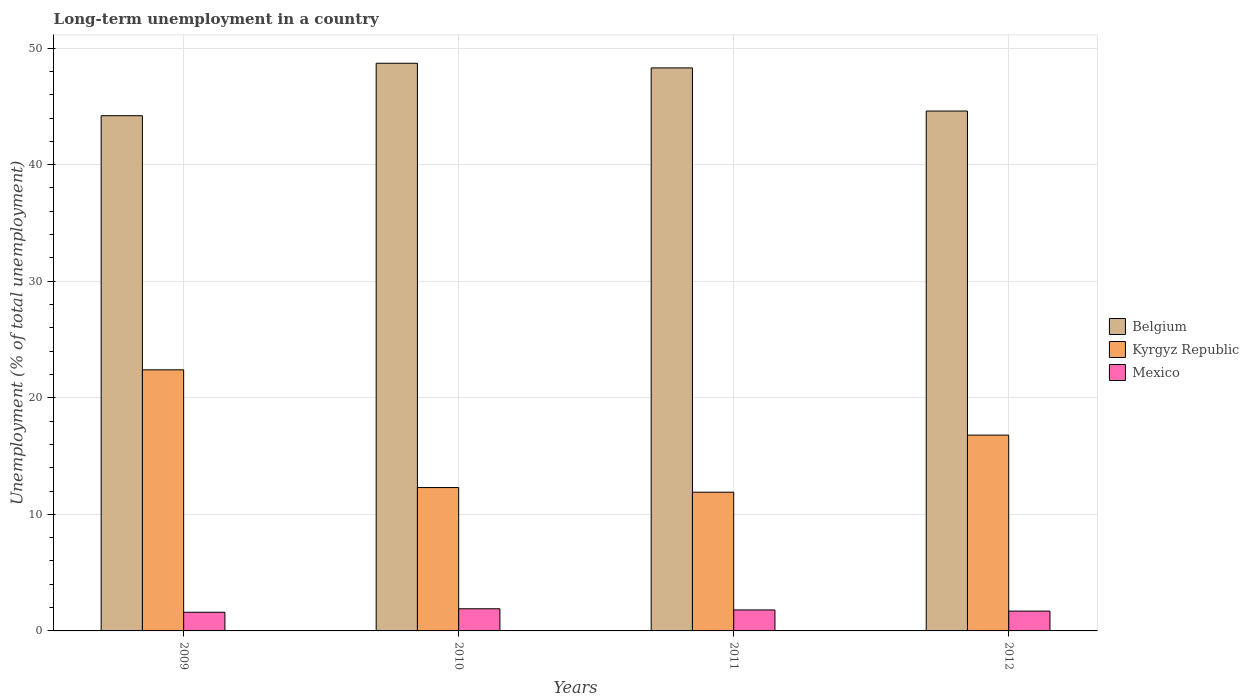How many groups of bars are there?
Offer a very short reply. 4. Are the number of bars on each tick of the X-axis equal?
Make the answer very short. Yes. How many bars are there on the 2nd tick from the left?
Ensure brevity in your answer.  3. What is the label of the 3rd group of bars from the left?
Ensure brevity in your answer.  2011. What is the percentage of long-term unemployed population in Belgium in 2012?
Offer a very short reply. 44.6. Across all years, what is the maximum percentage of long-term unemployed population in Belgium?
Your answer should be compact. 48.7. Across all years, what is the minimum percentage of long-term unemployed population in Kyrgyz Republic?
Ensure brevity in your answer.  11.9. What is the total percentage of long-term unemployed population in Kyrgyz Republic in the graph?
Offer a very short reply. 63.4. What is the difference between the percentage of long-term unemployed population in Mexico in 2009 and that in 2011?
Keep it short and to the point. -0.2. What is the difference between the percentage of long-term unemployed population in Kyrgyz Republic in 2010 and the percentage of long-term unemployed population in Mexico in 2009?
Provide a succinct answer. 10.7. What is the average percentage of long-term unemployed population in Kyrgyz Republic per year?
Keep it short and to the point. 15.85. In the year 2012, what is the difference between the percentage of long-term unemployed population in Belgium and percentage of long-term unemployed population in Mexico?
Ensure brevity in your answer.  42.9. What is the ratio of the percentage of long-term unemployed population in Kyrgyz Republic in 2010 to that in 2011?
Ensure brevity in your answer.  1.03. Is the percentage of long-term unemployed population in Mexico in 2009 less than that in 2010?
Offer a terse response. Yes. Is the difference between the percentage of long-term unemployed population in Belgium in 2010 and 2011 greater than the difference between the percentage of long-term unemployed population in Mexico in 2010 and 2011?
Offer a very short reply. Yes. What is the difference between the highest and the second highest percentage of long-term unemployed population in Belgium?
Make the answer very short. 0.4. What is the difference between the highest and the lowest percentage of long-term unemployed population in Belgium?
Make the answer very short. 4.5. What does the 2nd bar from the left in 2010 represents?
Your answer should be compact. Kyrgyz Republic. What does the 3rd bar from the right in 2012 represents?
Your answer should be very brief. Belgium. Is it the case that in every year, the sum of the percentage of long-term unemployed population in Kyrgyz Republic and percentage of long-term unemployed population in Belgium is greater than the percentage of long-term unemployed population in Mexico?
Provide a short and direct response. Yes. Are all the bars in the graph horizontal?
Provide a short and direct response. No. What is the difference between two consecutive major ticks on the Y-axis?
Make the answer very short. 10. Does the graph contain grids?
Give a very brief answer. Yes. Where does the legend appear in the graph?
Provide a short and direct response. Center right. How many legend labels are there?
Ensure brevity in your answer.  3. What is the title of the graph?
Provide a succinct answer. Long-term unemployment in a country. What is the label or title of the Y-axis?
Your response must be concise. Unemployment (% of total unemployment). What is the Unemployment (% of total unemployment) in Belgium in 2009?
Your answer should be compact. 44.2. What is the Unemployment (% of total unemployment) of Kyrgyz Republic in 2009?
Provide a succinct answer. 22.4. What is the Unemployment (% of total unemployment) of Mexico in 2009?
Your answer should be very brief. 1.6. What is the Unemployment (% of total unemployment) of Belgium in 2010?
Your answer should be compact. 48.7. What is the Unemployment (% of total unemployment) in Kyrgyz Republic in 2010?
Provide a succinct answer. 12.3. What is the Unemployment (% of total unemployment) in Mexico in 2010?
Your answer should be very brief. 1.9. What is the Unemployment (% of total unemployment) of Belgium in 2011?
Offer a very short reply. 48.3. What is the Unemployment (% of total unemployment) of Kyrgyz Republic in 2011?
Give a very brief answer. 11.9. What is the Unemployment (% of total unemployment) in Mexico in 2011?
Provide a succinct answer. 1.8. What is the Unemployment (% of total unemployment) in Belgium in 2012?
Keep it short and to the point. 44.6. What is the Unemployment (% of total unemployment) of Kyrgyz Republic in 2012?
Your answer should be compact. 16.8. What is the Unemployment (% of total unemployment) in Mexico in 2012?
Make the answer very short. 1.7. Across all years, what is the maximum Unemployment (% of total unemployment) in Belgium?
Offer a very short reply. 48.7. Across all years, what is the maximum Unemployment (% of total unemployment) in Kyrgyz Republic?
Offer a terse response. 22.4. Across all years, what is the maximum Unemployment (% of total unemployment) in Mexico?
Provide a short and direct response. 1.9. Across all years, what is the minimum Unemployment (% of total unemployment) of Belgium?
Keep it short and to the point. 44.2. Across all years, what is the minimum Unemployment (% of total unemployment) in Kyrgyz Republic?
Your answer should be very brief. 11.9. Across all years, what is the minimum Unemployment (% of total unemployment) of Mexico?
Your answer should be compact. 1.6. What is the total Unemployment (% of total unemployment) of Belgium in the graph?
Provide a short and direct response. 185.8. What is the total Unemployment (% of total unemployment) in Kyrgyz Republic in the graph?
Offer a terse response. 63.4. What is the total Unemployment (% of total unemployment) in Mexico in the graph?
Your answer should be very brief. 7. What is the difference between the Unemployment (% of total unemployment) in Belgium in 2009 and that in 2010?
Provide a short and direct response. -4.5. What is the difference between the Unemployment (% of total unemployment) in Kyrgyz Republic in 2009 and that in 2010?
Provide a short and direct response. 10.1. What is the difference between the Unemployment (% of total unemployment) of Mexico in 2009 and that in 2010?
Keep it short and to the point. -0.3. What is the difference between the Unemployment (% of total unemployment) in Belgium in 2009 and that in 2011?
Your answer should be compact. -4.1. What is the difference between the Unemployment (% of total unemployment) in Mexico in 2009 and that in 2011?
Keep it short and to the point. -0.2. What is the difference between the Unemployment (% of total unemployment) of Mexico in 2009 and that in 2012?
Your answer should be very brief. -0.1. What is the difference between the Unemployment (% of total unemployment) of Belgium in 2010 and that in 2011?
Offer a very short reply. 0.4. What is the difference between the Unemployment (% of total unemployment) in Belgium in 2010 and that in 2012?
Make the answer very short. 4.1. What is the difference between the Unemployment (% of total unemployment) of Mexico in 2010 and that in 2012?
Your response must be concise. 0.2. What is the difference between the Unemployment (% of total unemployment) in Belgium in 2011 and that in 2012?
Offer a terse response. 3.7. What is the difference between the Unemployment (% of total unemployment) of Mexico in 2011 and that in 2012?
Provide a succinct answer. 0.1. What is the difference between the Unemployment (% of total unemployment) of Belgium in 2009 and the Unemployment (% of total unemployment) of Kyrgyz Republic in 2010?
Make the answer very short. 31.9. What is the difference between the Unemployment (% of total unemployment) of Belgium in 2009 and the Unemployment (% of total unemployment) of Mexico in 2010?
Give a very brief answer. 42.3. What is the difference between the Unemployment (% of total unemployment) of Belgium in 2009 and the Unemployment (% of total unemployment) of Kyrgyz Republic in 2011?
Your answer should be compact. 32.3. What is the difference between the Unemployment (% of total unemployment) in Belgium in 2009 and the Unemployment (% of total unemployment) in Mexico in 2011?
Make the answer very short. 42.4. What is the difference between the Unemployment (% of total unemployment) in Kyrgyz Republic in 2009 and the Unemployment (% of total unemployment) in Mexico in 2011?
Ensure brevity in your answer.  20.6. What is the difference between the Unemployment (% of total unemployment) in Belgium in 2009 and the Unemployment (% of total unemployment) in Kyrgyz Republic in 2012?
Make the answer very short. 27.4. What is the difference between the Unemployment (% of total unemployment) of Belgium in 2009 and the Unemployment (% of total unemployment) of Mexico in 2012?
Provide a succinct answer. 42.5. What is the difference between the Unemployment (% of total unemployment) of Kyrgyz Republic in 2009 and the Unemployment (% of total unemployment) of Mexico in 2012?
Offer a terse response. 20.7. What is the difference between the Unemployment (% of total unemployment) in Belgium in 2010 and the Unemployment (% of total unemployment) in Kyrgyz Republic in 2011?
Ensure brevity in your answer.  36.8. What is the difference between the Unemployment (% of total unemployment) in Belgium in 2010 and the Unemployment (% of total unemployment) in Mexico in 2011?
Provide a short and direct response. 46.9. What is the difference between the Unemployment (% of total unemployment) in Belgium in 2010 and the Unemployment (% of total unemployment) in Kyrgyz Republic in 2012?
Your response must be concise. 31.9. What is the difference between the Unemployment (% of total unemployment) of Belgium in 2010 and the Unemployment (% of total unemployment) of Mexico in 2012?
Give a very brief answer. 47. What is the difference between the Unemployment (% of total unemployment) in Belgium in 2011 and the Unemployment (% of total unemployment) in Kyrgyz Republic in 2012?
Your answer should be very brief. 31.5. What is the difference between the Unemployment (% of total unemployment) in Belgium in 2011 and the Unemployment (% of total unemployment) in Mexico in 2012?
Offer a very short reply. 46.6. What is the difference between the Unemployment (% of total unemployment) in Kyrgyz Republic in 2011 and the Unemployment (% of total unemployment) in Mexico in 2012?
Your answer should be compact. 10.2. What is the average Unemployment (% of total unemployment) of Belgium per year?
Give a very brief answer. 46.45. What is the average Unemployment (% of total unemployment) in Kyrgyz Republic per year?
Your answer should be compact. 15.85. In the year 2009, what is the difference between the Unemployment (% of total unemployment) of Belgium and Unemployment (% of total unemployment) of Kyrgyz Republic?
Your answer should be very brief. 21.8. In the year 2009, what is the difference between the Unemployment (% of total unemployment) of Belgium and Unemployment (% of total unemployment) of Mexico?
Make the answer very short. 42.6. In the year 2009, what is the difference between the Unemployment (% of total unemployment) of Kyrgyz Republic and Unemployment (% of total unemployment) of Mexico?
Offer a terse response. 20.8. In the year 2010, what is the difference between the Unemployment (% of total unemployment) of Belgium and Unemployment (% of total unemployment) of Kyrgyz Republic?
Give a very brief answer. 36.4. In the year 2010, what is the difference between the Unemployment (% of total unemployment) in Belgium and Unemployment (% of total unemployment) in Mexico?
Ensure brevity in your answer.  46.8. In the year 2011, what is the difference between the Unemployment (% of total unemployment) of Belgium and Unemployment (% of total unemployment) of Kyrgyz Republic?
Your answer should be compact. 36.4. In the year 2011, what is the difference between the Unemployment (% of total unemployment) in Belgium and Unemployment (% of total unemployment) in Mexico?
Ensure brevity in your answer.  46.5. In the year 2012, what is the difference between the Unemployment (% of total unemployment) of Belgium and Unemployment (% of total unemployment) of Kyrgyz Republic?
Ensure brevity in your answer.  27.8. In the year 2012, what is the difference between the Unemployment (% of total unemployment) of Belgium and Unemployment (% of total unemployment) of Mexico?
Give a very brief answer. 42.9. In the year 2012, what is the difference between the Unemployment (% of total unemployment) in Kyrgyz Republic and Unemployment (% of total unemployment) in Mexico?
Offer a very short reply. 15.1. What is the ratio of the Unemployment (% of total unemployment) of Belgium in 2009 to that in 2010?
Provide a succinct answer. 0.91. What is the ratio of the Unemployment (% of total unemployment) of Kyrgyz Republic in 2009 to that in 2010?
Provide a short and direct response. 1.82. What is the ratio of the Unemployment (% of total unemployment) of Mexico in 2009 to that in 2010?
Make the answer very short. 0.84. What is the ratio of the Unemployment (% of total unemployment) in Belgium in 2009 to that in 2011?
Keep it short and to the point. 0.92. What is the ratio of the Unemployment (% of total unemployment) in Kyrgyz Republic in 2009 to that in 2011?
Make the answer very short. 1.88. What is the ratio of the Unemployment (% of total unemployment) of Belgium in 2009 to that in 2012?
Your answer should be very brief. 0.99. What is the ratio of the Unemployment (% of total unemployment) of Kyrgyz Republic in 2009 to that in 2012?
Your answer should be compact. 1.33. What is the ratio of the Unemployment (% of total unemployment) in Belgium in 2010 to that in 2011?
Ensure brevity in your answer.  1.01. What is the ratio of the Unemployment (% of total unemployment) in Kyrgyz Republic in 2010 to that in 2011?
Your answer should be very brief. 1.03. What is the ratio of the Unemployment (% of total unemployment) in Mexico in 2010 to that in 2011?
Ensure brevity in your answer.  1.06. What is the ratio of the Unemployment (% of total unemployment) in Belgium in 2010 to that in 2012?
Your answer should be very brief. 1.09. What is the ratio of the Unemployment (% of total unemployment) in Kyrgyz Republic in 2010 to that in 2012?
Offer a very short reply. 0.73. What is the ratio of the Unemployment (% of total unemployment) of Mexico in 2010 to that in 2012?
Ensure brevity in your answer.  1.12. What is the ratio of the Unemployment (% of total unemployment) of Belgium in 2011 to that in 2012?
Your answer should be very brief. 1.08. What is the ratio of the Unemployment (% of total unemployment) of Kyrgyz Republic in 2011 to that in 2012?
Your answer should be very brief. 0.71. What is the ratio of the Unemployment (% of total unemployment) in Mexico in 2011 to that in 2012?
Provide a succinct answer. 1.06. What is the difference between the highest and the second highest Unemployment (% of total unemployment) in Kyrgyz Republic?
Give a very brief answer. 5.6. What is the difference between the highest and the second highest Unemployment (% of total unemployment) in Mexico?
Offer a very short reply. 0.1. What is the difference between the highest and the lowest Unemployment (% of total unemployment) of Belgium?
Provide a succinct answer. 4.5. What is the difference between the highest and the lowest Unemployment (% of total unemployment) in Mexico?
Make the answer very short. 0.3. 